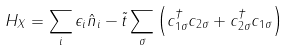Convert formula to latex. <formula><loc_0><loc_0><loc_500><loc_500>H _ { X } = \sum _ { i } \epsilon _ { i } \hat { n } _ { i } - \tilde { t } \sum _ { \sigma } \left ( c _ { 1 \sigma } ^ { \dagger } c _ { 2 \sigma } + c _ { 2 \sigma } ^ { \dagger } c _ { 1 \sigma } \right )</formula> 